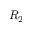<formula> <loc_0><loc_0><loc_500><loc_500>R _ { 2 }</formula> 